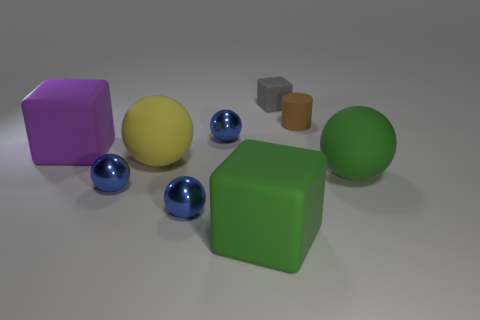There is a large rubber object behind the large yellow rubber thing; does it have the same shape as the green matte thing that is left of the big green sphere? yes 